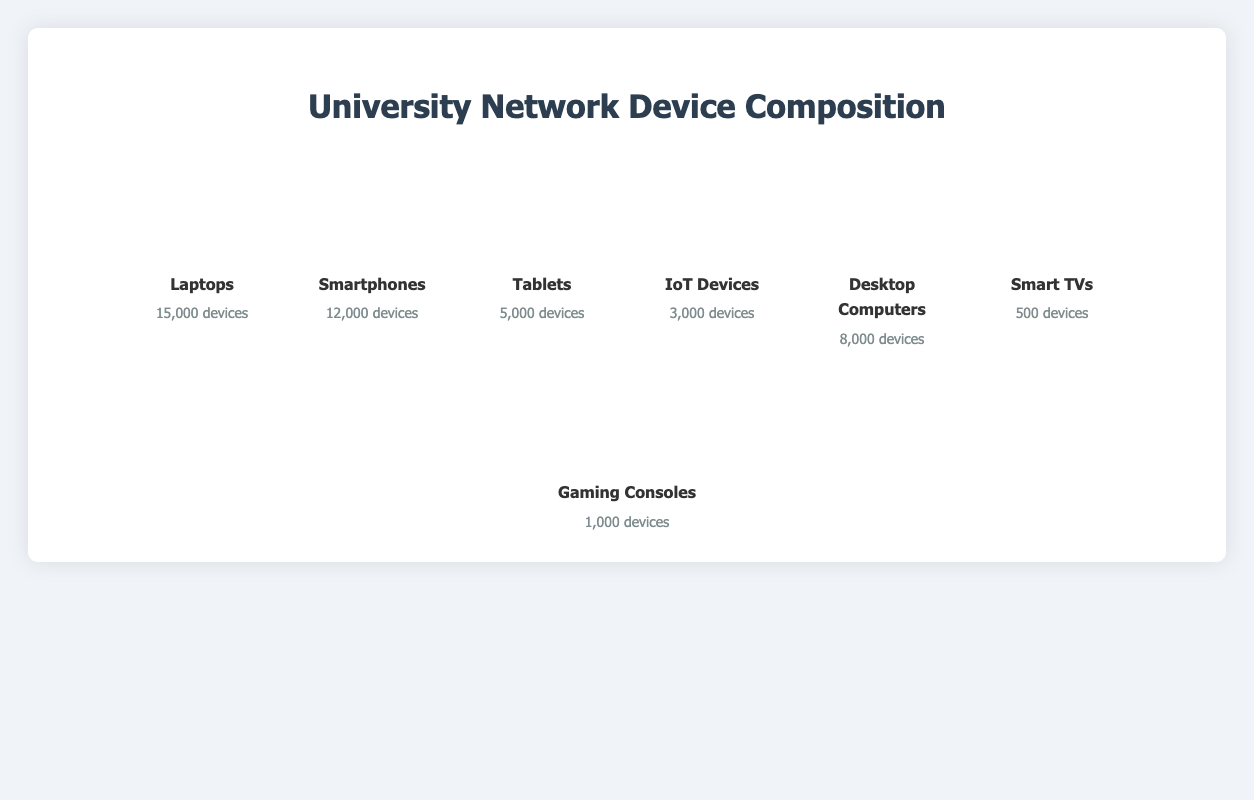Which device type has the highest number of devices connected to the university network? The figure shows different types of devices along with their counts. By observing the counts, we see that Laptops have the highest number of devices connected at 15,000.
Answer: Laptops Which device type has the lowest count of devices connected to the university network? From the visual representation of the counts, Smart TVs have the lowest count with only 500 devices.
Answer: Smart TVs How many more laptops than desktop computers are connected to the university network? Laptops have 15,000 devices and Desktop Computers have 8,000 devices. Subtract the number of Desktop Computers from the number of Laptops: 15,000 - 8,000 = 7,000.
Answer: 7,000 What is the total number of IoT Devices and Gaming Consoles connected to the network? IoT Devices have 3,000 devices and Gaming Consoles have 1,000 devices. Adding these counts together: 3,000 + 1,000 = 4,000.
Answer: 4,000 How many times more laptops are there than Smart TVs? Laptops have 15,000 devices and Smart TVs have 500 devices. Divide the number of Laptops by the number of Smart TVs: 15,000 / 500 = 30.
Answer: 30 What is the combined count of Smartphones, Tablets, and IoT Devices? The count of Smartphones is 12,000, Tablets is 5,000, and IoT Devices is 3,000. Summing these values: 12,000 + 5,000 + 3,000 = 20,000.
Answer: 20,000 Which device type categories are represented in the figure? The figure represents seven device type categories: Laptops, Smartphones, Tablets, IoT Devices, Desktop Computers, Smart TVs, and Gaming Consoles.
Answer: Laptops, Smartphones, Tablets, IoT Devices, Desktop Computers, Smart TVs, Gaming Consoles Are there more Tablets or Gaming Consoles connected to the network? Tablets have 5,000 devices and Gaming Consoles have 1,000 devices. Comparing these values, the number of Tablets is greater.
Answer: Tablets What is the total number of all devices connected to the university network? Adding the counts of all devices: 15,000 (Laptops) + 12,000 (Smartphones) + 5,000 (Tablets) + 3,000 (IoT Devices) + 8,000 (Desktop Computers) + 500 (Smart TVs) + 1,000 (Gaming Consoles) = 44,500.
Answer: 44,500 